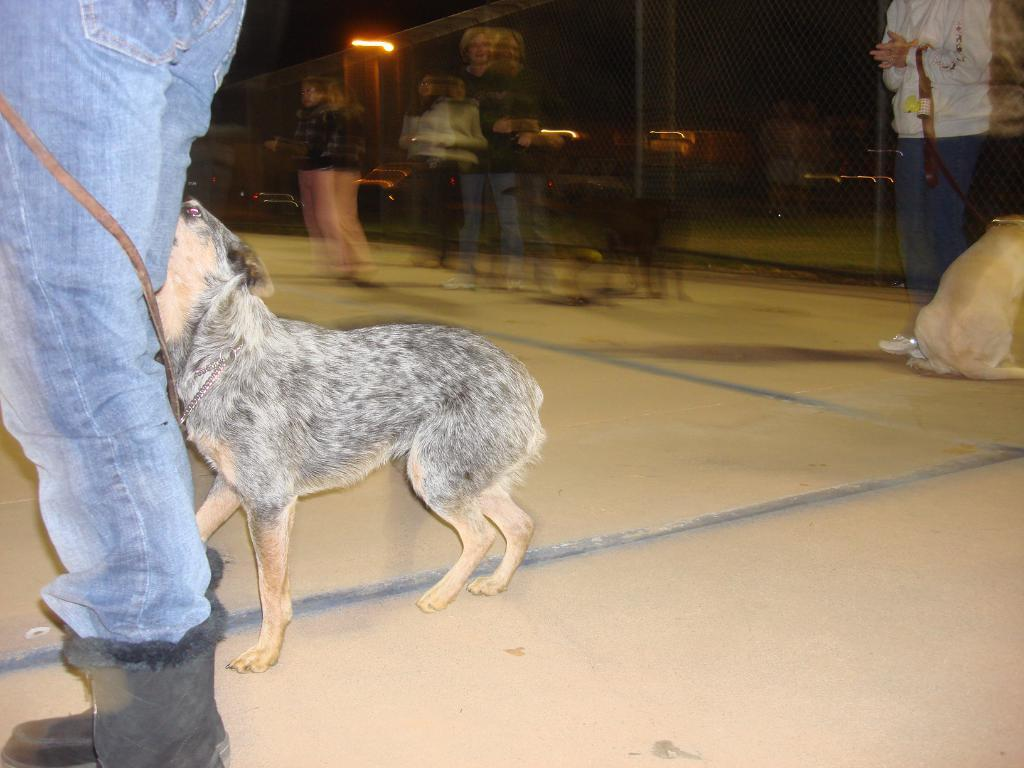What animal is on the road in the image? There is a dog on the road in the image. Can you describe the person behind the dog? The person is behind the dog in the image. What type of trousers is the dog wearing in the image? Dogs do not wear trousers, so this question cannot be answered. What drug is the person holding in the image? There is no drug present in the image; it only features a dog on the road and a person behind the dog. 